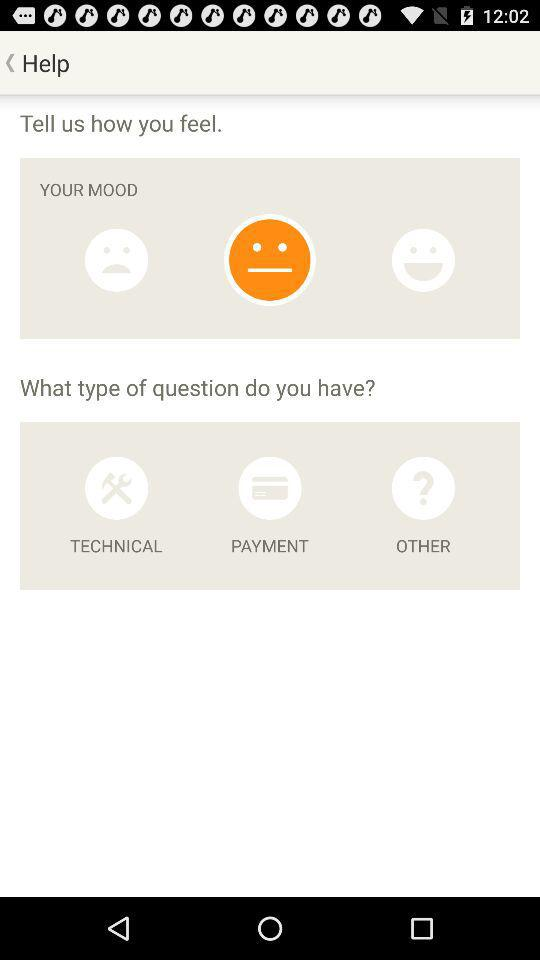What are the three options available for the question type? The three available options are "TECHNICAL", "PAYMENT" and "OTHER". 